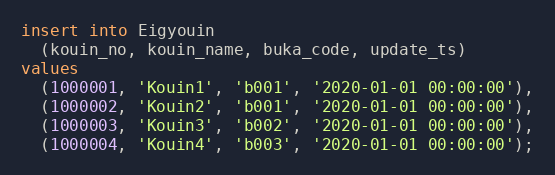Convert code to text. <code><loc_0><loc_0><loc_500><loc_500><_SQL_>insert into Eigyouin
  (kouin_no, kouin_name, buka_code, update_ts)
values
  (1000001, 'Kouin1', 'b001', '2020-01-01 00:00:00'),
  (1000002, 'Kouin2', 'b001', '2020-01-01 00:00:00'),
  (1000003, 'Kouin3', 'b002', '2020-01-01 00:00:00'),
  (1000004, 'Kouin4', 'b003', '2020-01-01 00:00:00');
</code> 